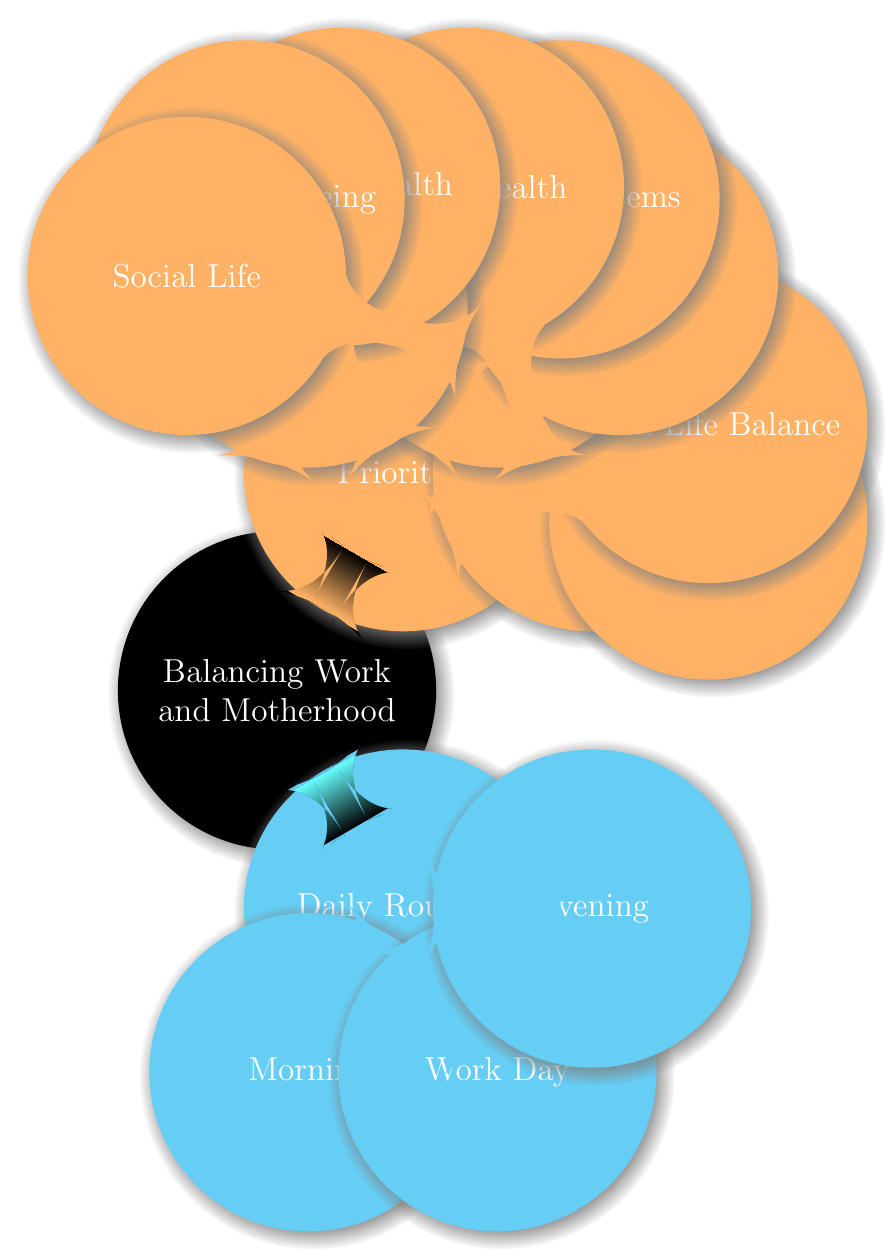What time does the morning routine start? According to the diagram under the "Morning Routine" node, the "Wake Up" time is specified as 6:00 AM.
Answer: 6:00 AM How many main components are there under "Daily Routines"? The "Daily Routines" node has three sub-nodes: "Morning", "Work Day", and "Evening", making a total of three components.
Answer: 3 What is one focus area listed under "Work" priorities? Under the "Work" node, one of the items listed in "Focus Areas" is "Productivity", which is a focus area of work priorities.
Answer: Productivity What is the last activity listed in the evening routine? In the "Evening Routine" section, the last mentioned activity before sleep is "Sleep" which is scheduled for 10:00 PM.
Answer: Sleep What are the three self-care categories mentioned? Under the "Self-Care" node, there are three sub-nodes: "Physical Health", "Mental Well-being", and "Social Life", indicating the categories of self-care.
Answer: Physical Health, Mental Well-being, Social Life Which support system is suggested for "Motherhood"? One of the support systems mentioned under the "Motherhood" node is "Partner", which is a suggested support for motherhood.
Answer: Partner What is the duration allocated for personal care in the morning? The "Personal Care" section of the morning routine states that it takes 30 minutes for showering and dressing.
Answer: 30 minutes What types of mental health support are mentioned? Under the "Mental Health" category within "Motherhood", the types of support listed are "Therapy", "Support Groups", and "Self-care", indicating various mental health supports.
Answer: Therapy, Support Groups, Self-care How many breaks are scheduled during the work day? The "Work Day" section specifies there are three breaks: "Morning break", "Lunch break", and "Afternoon break", totaling three scheduled breaks.
Answer: 3 